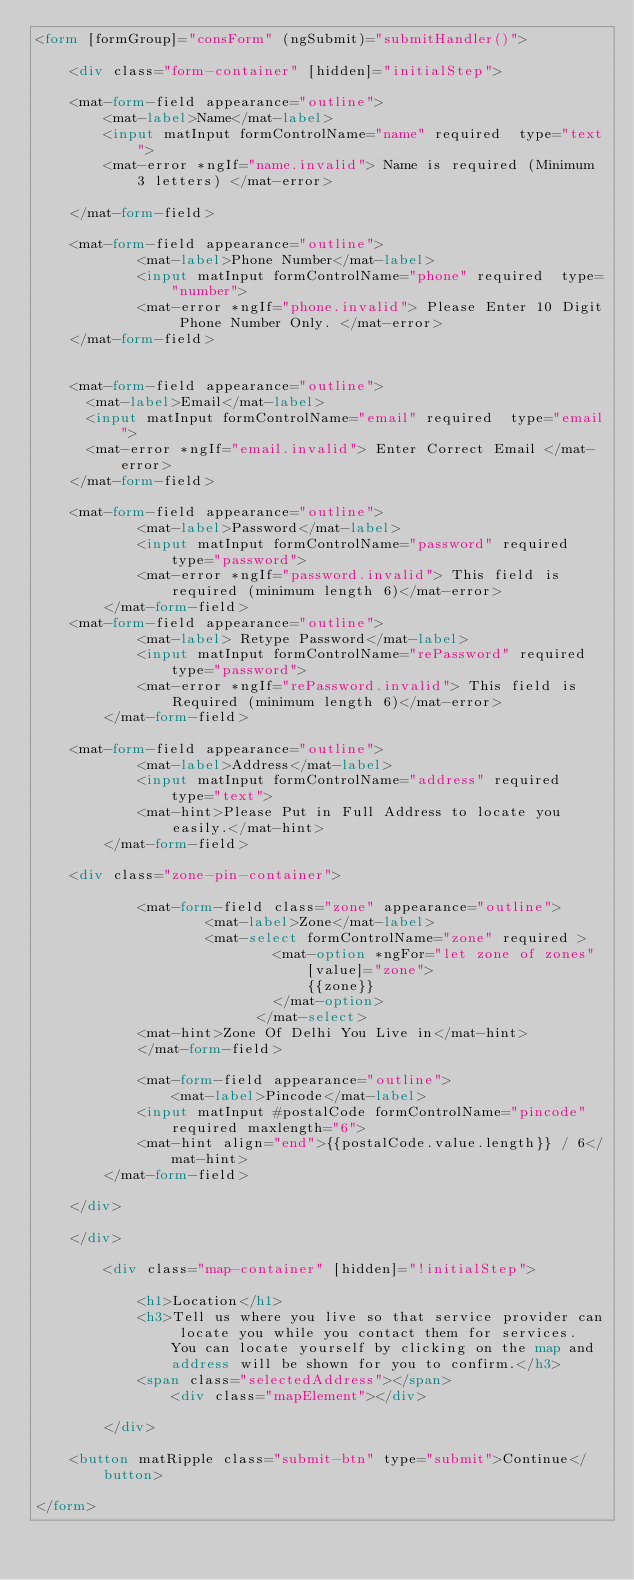<code> <loc_0><loc_0><loc_500><loc_500><_HTML_><form [formGroup]="consForm" (ngSubmit)="submitHandler()">

    <div class="form-container" [hidden]="initialStep">

    <mat-form-field appearance="outline">
        <mat-label>Name</mat-label>
        <input matInput formControlName="name" required  type="text">
        <mat-error *ngIf="name.invalid"> Name is required (Minimum 3 letters) </mat-error>
        
    </mat-form-field>

    <mat-form-field appearance="outline">
            <mat-label>Phone Number</mat-label>
            <input matInput formControlName="phone" required  type="number">
            <mat-error *ngIf="phone.invalid"> Please Enter 10 Digit Phone Number Only. </mat-error>
    </mat-form-field>
    

    <mat-form-field appearance="outline">
      <mat-label>Email</mat-label>
      <input matInput formControlName="email" required  type="email">
      <mat-error *ngIf="email.invalid"> Enter Correct Email </mat-error>
    </mat-form-field>

    <mat-form-field appearance="outline">
            <mat-label>Password</mat-label>
            <input matInput formControlName="password" required type="password">
            <mat-error *ngIf="password.invalid"> This field is required (minimum length 6)</mat-error>
        </mat-form-field>
    <mat-form-field appearance="outline">
            <mat-label> Retype Password</mat-label>
            <input matInput formControlName="rePassword" required  type="password">
            <mat-error *ngIf="rePassword.invalid"> This field is Required (minimum length 6)</mat-error>
        </mat-form-field>

    <mat-form-field appearance="outline">
            <mat-label>Address</mat-label>
            <input matInput formControlName="address" required  type="text">
            <mat-hint>Please Put in Full Address to locate you easily.</mat-hint>
        </mat-form-field>
     
    <div class="zone-pin-container">

            <mat-form-field class="zone" appearance="outline">
                    <mat-label>Zone</mat-label>
                    <mat-select formControlName="zone" required >
                            <mat-option *ngFor="let zone of zones" [value]="zone">
                                {{zone}}
                            </mat-option>
                          </mat-select>
            <mat-hint>Zone Of Delhi You Live in</mat-hint>
            </mat-form-field>
    
            <mat-form-field appearance="outline">
                <mat-label>Pincode</mat-label>
            <input matInput #postalCode formControlName="pincode" required maxlength="6">
            <mat-hint align="end">{{postalCode.value.length}} / 6</mat-hint>
        </mat-form-field>

    </div>

    </div>

        <div class="map-container" [hidden]="!initialStep">

            <h1>Location</h1>
            <h3>Tell us where you live so that service provider can locate you while you contact them for services. You can locate yourself by clicking on the map and address will be shown for you to confirm.</h3>
            <span class="selectedAddress"></span>
                <div class="mapElement"></div>
            
        </div>

    <button matRipple class="submit-btn" type="submit">Continue</button>

</form>

</code> 